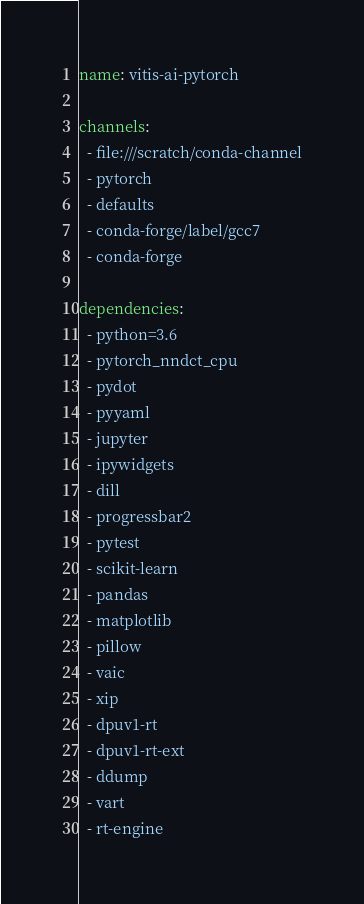<code> <loc_0><loc_0><loc_500><loc_500><_YAML_>name: vitis-ai-pytorch

channels:
  - file:///scratch/conda-channel
  - pytorch
  - defaults
  - conda-forge/label/gcc7
  - conda-forge

dependencies:
  - python=3.6
  - pytorch_nndct_cpu
  - pydot
  - pyyaml
  - jupyter
  - ipywidgets
  - dill
  - progressbar2
  - pytest
  - scikit-learn
  - pandas
  - matplotlib
  - pillow
  - vaic
  - xip
  - dpuv1-rt
  - dpuv1-rt-ext
  - ddump
  - vart
  - rt-engine
</code> 